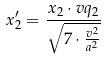<formula> <loc_0><loc_0><loc_500><loc_500>x _ { 2 } ^ { \prime } = \frac { x _ { 2 } \cdot v q _ { 2 } } { \sqrt { 7 \cdot \frac { v ^ { 2 } } { a ^ { 2 } } } }</formula> 